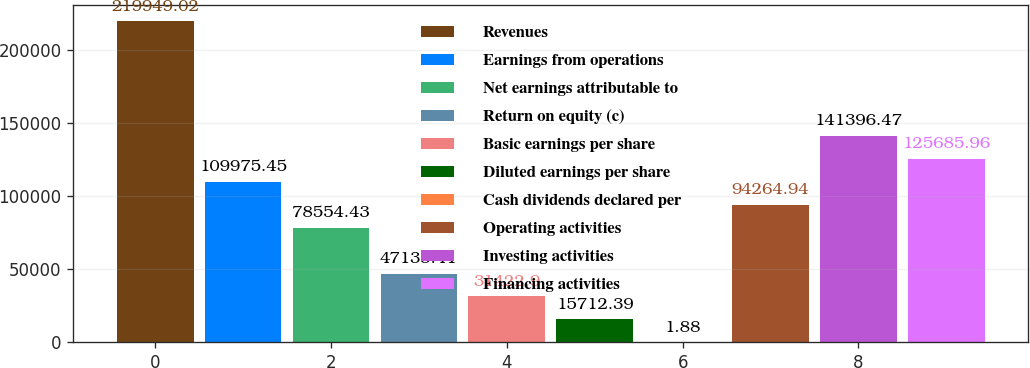<chart> <loc_0><loc_0><loc_500><loc_500><bar_chart><fcel>Revenues<fcel>Earnings from operations<fcel>Net earnings attributable to<fcel>Return on equity (c)<fcel>Basic earnings per share<fcel>Diluted earnings per share<fcel>Cash dividends declared per<fcel>Operating activities<fcel>Investing activities<fcel>Financing activities<nl><fcel>219949<fcel>109975<fcel>78554.4<fcel>47133.4<fcel>31422.9<fcel>15712.4<fcel>1.88<fcel>94264.9<fcel>141396<fcel>125686<nl></chart> 